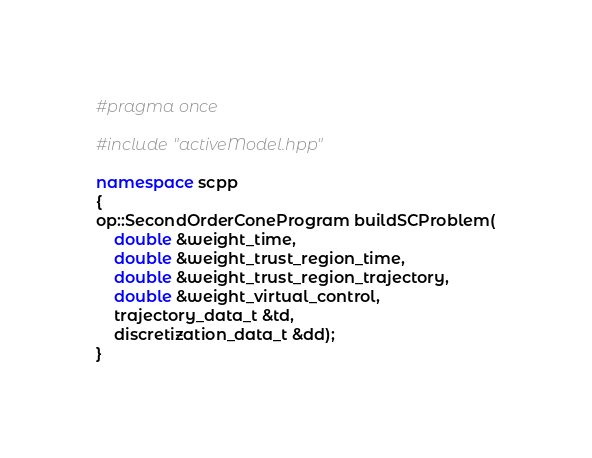Convert code to text. <code><loc_0><loc_0><loc_500><loc_500><_C++_>#pragma once

#include "activeModel.hpp"

namespace scpp
{
op::SecondOrderConeProgram buildSCProblem(
    double &weight_time,
    double &weight_trust_region_time,
    double &weight_trust_region_trajectory,
    double &weight_virtual_control,
    trajectory_data_t &td,
    discretization_data_t &dd);
}
</code> 